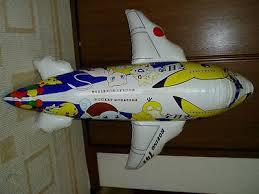Is there a aeroplane in the image? Yes 